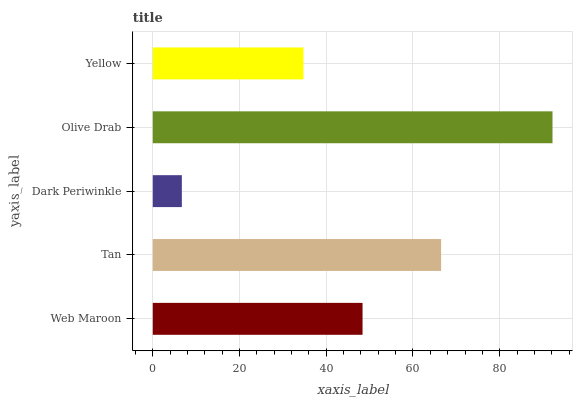Is Dark Periwinkle the minimum?
Answer yes or no. Yes. Is Olive Drab the maximum?
Answer yes or no. Yes. Is Tan the minimum?
Answer yes or no. No. Is Tan the maximum?
Answer yes or no. No. Is Tan greater than Web Maroon?
Answer yes or no. Yes. Is Web Maroon less than Tan?
Answer yes or no. Yes. Is Web Maroon greater than Tan?
Answer yes or no. No. Is Tan less than Web Maroon?
Answer yes or no. No. Is Web Maroon the high median?
Answer yes or no. Yes. Is Web Maroon the low median?
Answer yes or no. Yes. Is Olive Drab the high median?
Answer yes or no. No. Is Tan the low median?
Answer yes or no. No. 